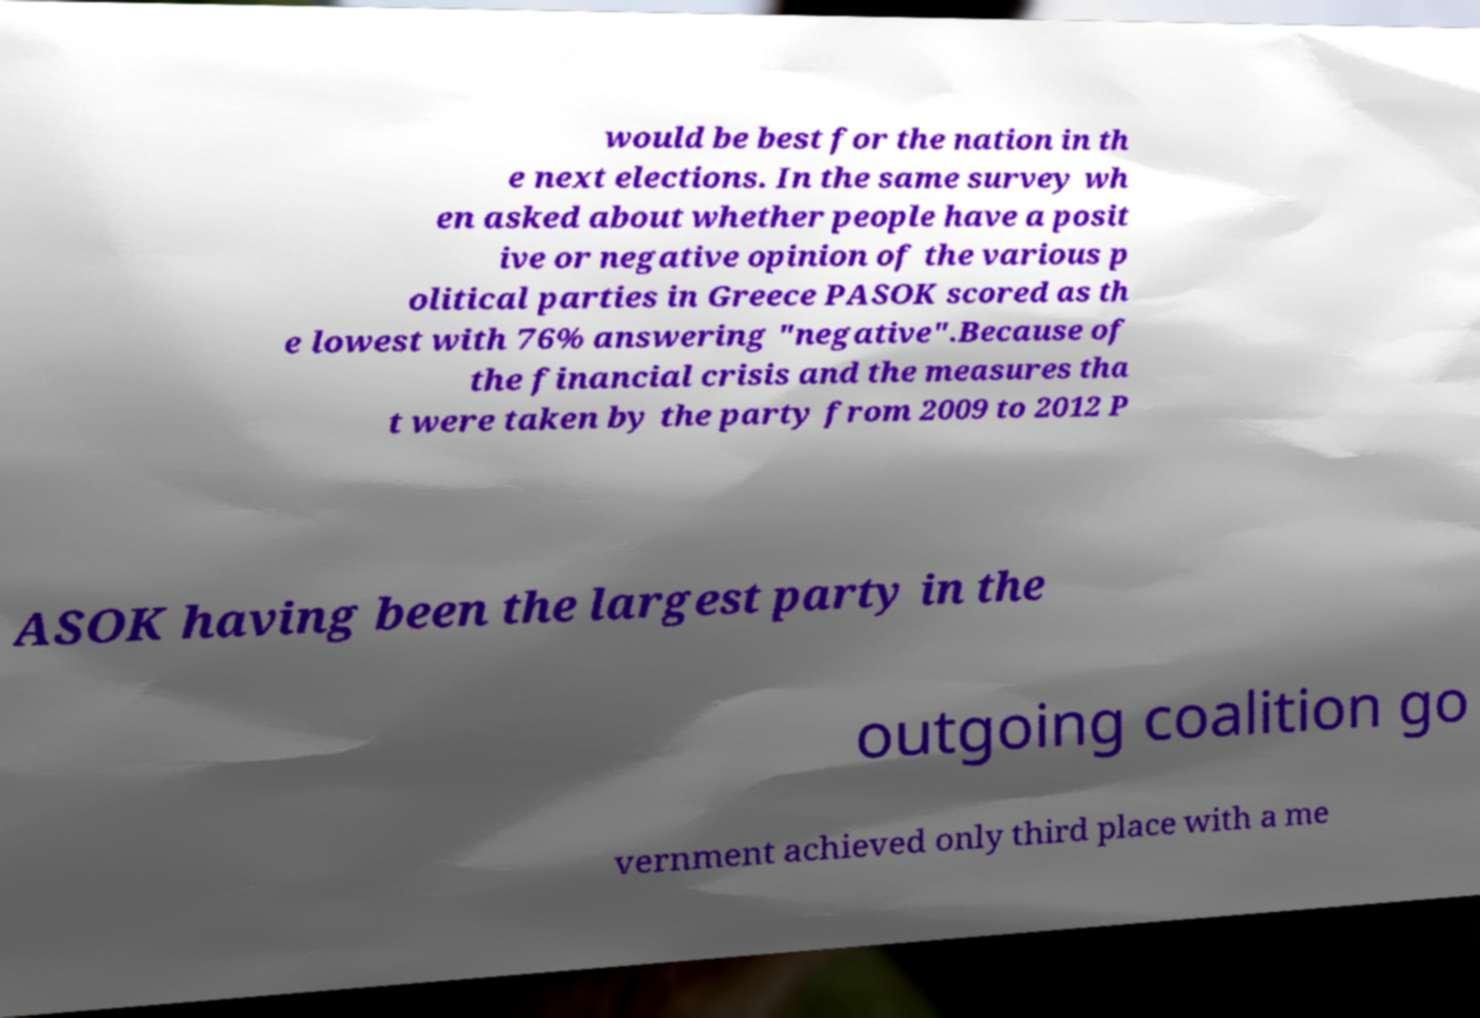There's text embedded in this image that I need extracted. Can you transcribe it verbatim? would be best for the nation in th e next elections. In the same survey wh en asked about whether people have a posit ive or negative opinion of the various p olitical parties in Greece PASOK scored as th e lowest with 76% answering "negative".Because of the financial crisis and the measures tha t were taken by the party from 2009 to 2012 P ASOK having been the largest party in the outgoing coalition go vernment achieved only third place with a me 